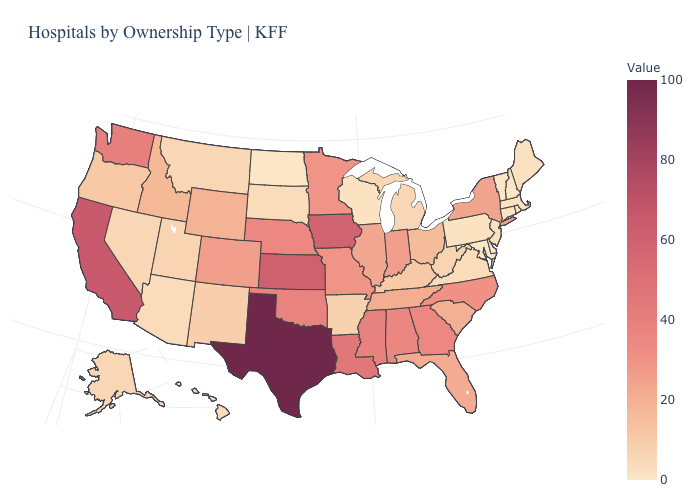Does the map have missing data?
Give a very brief answer. No. Among the states that border Wyoming , which have the highest value?
Answer briefly. Nebraska. Which states have the highest value in the USA?
Give a very brief answer. Texas. Among the states that border Virginia , does Tennessee have the lowest value?
Write a very short answer. No. Is the legend a continuous bar?
Be succinct. Yes. Does New York have the highest value in the Northeast?
Concise answer only. Yes. Among the states that border Maryland , does Delaware have the highest value?
Write a very short answer. No. 